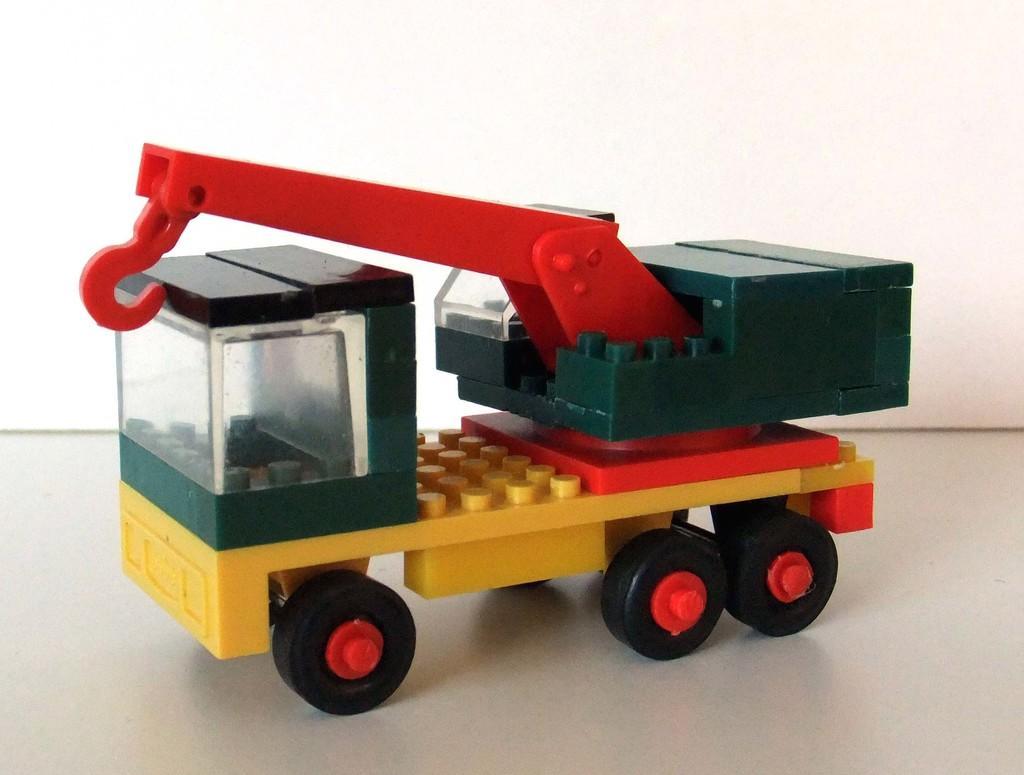Describe this image in one or two sentences. In this image there is one Toy of a truck is in middle of this image and there is a wall in the background. 